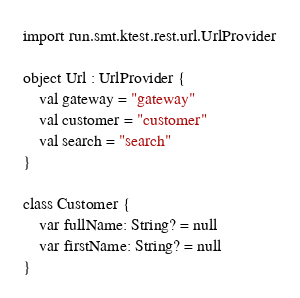Convert code to text. <code><loc_0><loc_0><loc_500><loc_500><_Kotlin_>import run.smt.ktest.rest.url.UrlProvider

object Url : UrlProvider {
    val gateway = "gateway"
    val customer = "customer"
    val search = "search"
}

class Customer {
    var fullName: String? = null
    var firstName: String? = null
}

</code> 